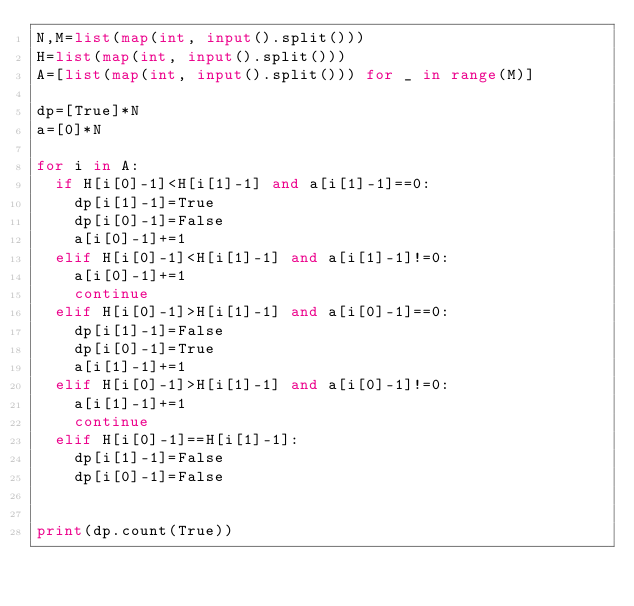<code> <loc_0><loc_0><loc_500><loc_500><_Python_>N,M=list(map(int, input().split()))
H=list(map(int, input().split()))
A=[list(map(int, input().split())) for _ in range(M)]

dp=[True]*N
a=[0]*N

for i in A:
  if H[i[0]-1]<H[i[1]-1] and a[i[1]-1]==0:
    dp[i[1]-1]=True
    dp[i[0]-1]=False
    a[i[0]-1]+=1
  elif H[i[0]-1]<H[i[1]-1] and a[i[1]-1]!=0:
    a[i[0]-1]+=1
    continue
  elif H[i[0]-1]>H[i[1]-1] and a[i[0]-1]==0:
    dp[i[1]-1]=False
    dp[i[0]-1]=True
    a[i[1]-1]+=1
  elif H[i[0]-1]>H[i[1]-1] and a[i[0]-1]!=0:
    a[i[1]-1]+=1
    continue
  elif H[i[0]-1]==H[i[1]-1]:
    dp[i[1]-1]=False
    dp[i[0]-1]=False
  

print(dp.count(True))</code> 